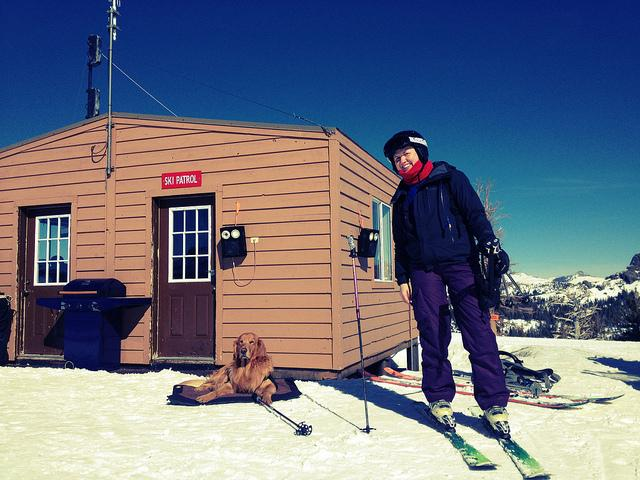What type of sign is on the building? ski patrol 